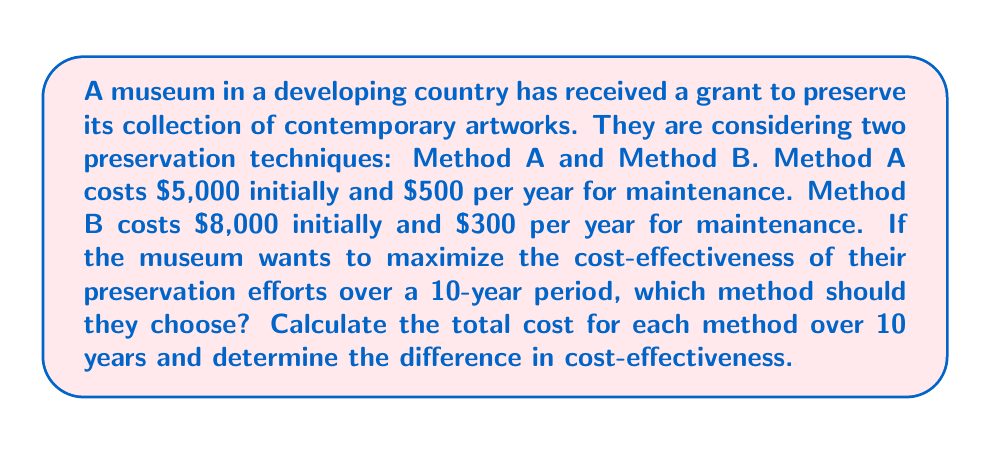Teach me how to tackle this problem. Let's approach this step-by-step:

1. Calculate the total cost for Method A over 10 years:
   Initial cost: $5,000
   Annual maintenance: $500 × 10 years = $5,000
   Total cost A = $5,000 + $5,000 = $10,000

2. Calculate the total cost for Method B over 10 years:
   Initial cost: $8,000
   Annual maintenance: $300 × 10 years = $3,000
   Total cost B = $8,000 + $3,000 = $11,000

3. Compare the total costs:
   Difference = Total cost B - Total cost A
   Difference = $11,000 - $10,000 = $1,000

4. Calculate the annual cost-effectiveness:
   Method A: $10,000 ÷ 10 years = $1,000 per year
   Method B: $11,000 ÷ 10 years = $1,100 per year

5. Determine the difference in annual cost-effectiveness:
   $1,100 - $1,000 = $100 per year

Therefore, Method A is more cost-effective over the 10-year period. It saves the museum $1,000 in total, or $100 per year compared to Method B.

We can express this mathematically as:

$$\text{Total Cost}_A = C_i + C_m \times t$$
$$\text{Total Cost}_B = C_i + C_m \times t$$

Where:
$C_i$ = Initial cost
$C_m$ = Annual maintenance cost
$t$ = Time period in years

For Method A: $\text{Total Cost}_A = 5000 + 500 \times 10 = 10000$
For Method B: $\text{Total Cost}_B = 8000 + 300 \times 10 = 11000$

The difference in cost-effectiveness is:

$$\Delta \text{Cost} = \text{Total Cost}_B - \text{Total Cost}_A = 11000 - 10000 = 1000$$

Annual cost-effectiveness difference:

$$\Delta \text{Annual Cost} = \frac{\Delta \text{Cost}}{t} = \frac{1000}{10} = 100$$
Answer: Method A; $1,000 more cost-effective over 10 years 